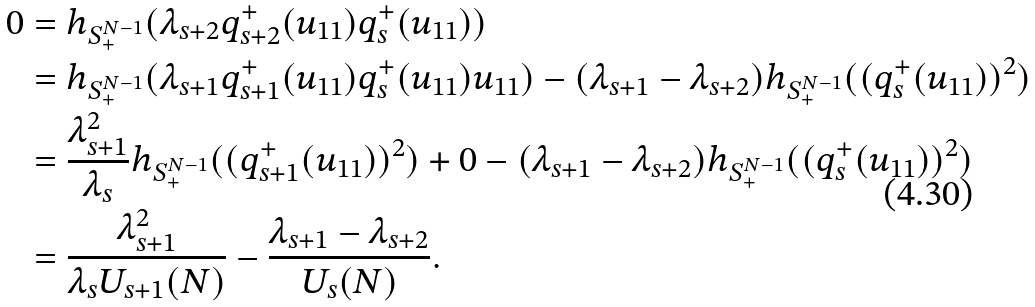<formula> <loc_0><loc_0><loc_500><loc_500>0 & = h _ { S ^ { N - 1 } _ { + } } ( \lambda _ { s + 2 } q ^ { + } _ { s + 2 } ( u _ { 1 1 } ) q ^ { + } _ { s } ( u _ { 1 1 } ) ) \\ & = h _ { S ^ { N - 1 } _ { + } } ( \lambda _ { s + 1 } q ^ { + } _ { s + 1 } ( u _ { 1 1 } ) q ^ { + } _ { s } ( u _ { 1 1 } ) u _ { 1 1 } ) - ( \lambda _ { s + 1 } - \lambda _ { s + 2 } ) h _ { S ^ { N - 1 } _ { + } } ( ( q ^ { + } _ { s } ( u _ { 1 1 } ) ) ^ { 2 } ) \\ & = \frac { \lambda _ { s + 1 } ^ { 2 } } { \lambda _ { s } } h _ { S ^ { N - 1 } _ { + } } ( ( q ^ { + } _ { s + 1 } ( u _ { 1 1 } ) ) ^ { 2 } ) + 0 - ( \lambda _ { s + 1 } - \lambda _ { s + 2 } ) h _ { S ^ { N - 1 } _ { + } } ( ( q ^ { + } _ { s } ( u _ { 1 1 } ) ) ^ { 2 } ) \\ & = \frac { \lambda _ { s + 1 } ^ { 2 } } { \lambda _ { s } U _ { s + 1 } ( N ) } - \frac { \lambda _ { s + 1 } - \lambda _ { s + 2 } } { U _ { s } ( N ) } .</formula> 